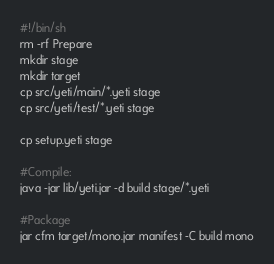<code> <loc_0><loc_0><loc_500><loc_500><_Bash_>#!/bin/sh
rm -rf Prepare
mkdir stage
mkdir target
cp src/yeti/main/*.yeti stage
cp src/yeti/test/*.yeti stage

cp setup.yeti stage

#Compile:
java -jar lib/yeti.jar -d build stage/*.yeti

#Package
jar cfm target/mono.jar manifest -C build mono
</code> 